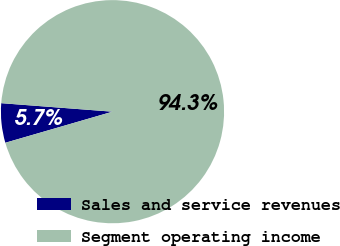Convert chart. <chart><loc_0><loc_0><loc_500><loc_500><pie_chart><fcel>Sales and service revenues<fcel>Segment operating income<nl><fcel>5.71%<fcel>94.29%<nl></chart> 